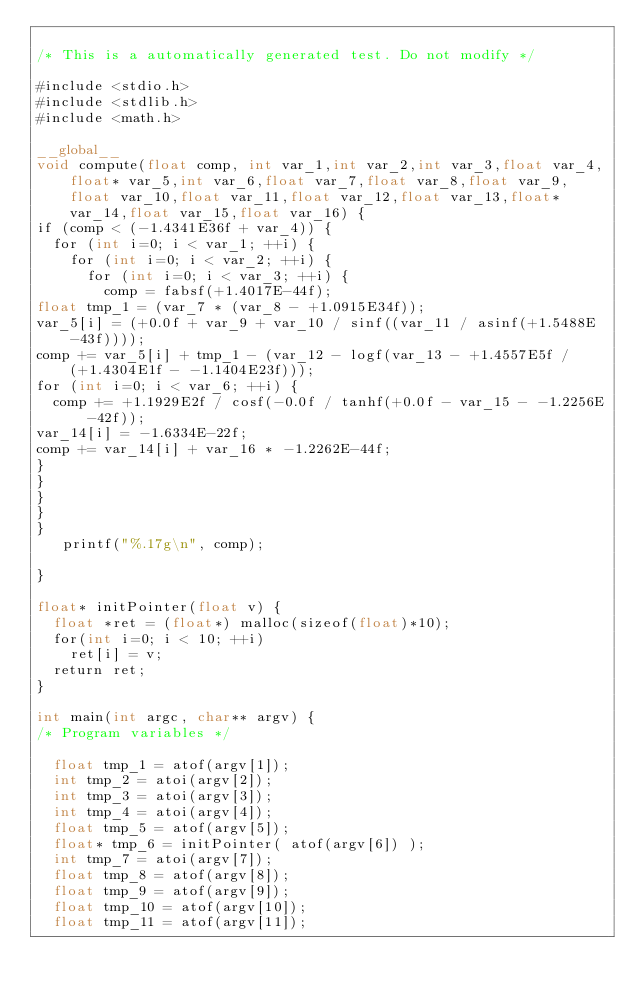Convert code to text. <code><loc_0><loc_0><loc_500><loc_500><_Cuda_>
/* This is a automatically generated test. Do not modify */

#include <stdio.h>
#include <stdlib.h>
#include <math.h>

__global__
void compute(float comp, int var_1,int var_2,int var_3,float var_4,float* var_5,int var_6,float var_7,float var_8,float var_9,float var_10,float var_11,float var_12,float var_13,float* var_14,float var_15,float var_16) {
if (comp < (-1.4341E36f + var_4)) {
  for (int i=0; i < var_1; ++i) {
    for (int i=0; i < var_2; ++i) {
      for (int i=0; i < var_3; ++i) {
        comp = fabsf(+1.4017E-44f);
float tmp_1 = (var_7 * (var_8 - +1.0915E34f));
var_5[i] = (+0.0f + var_9 + var_10 / sinf((var_11 / asinf(+1.5488E-43f))));
comp += var_5[i] + tmp_1 - (var_12 - logf(var_13 - +1.4557E5f / (+1.4304E1f - -1.1404E23f)));
for (int i=0; i < var_6; ++i) {
  comp += +1.1929E2f / cosf(-0.0f / tanhf(+0.0f - var_15 - -1.2256E-42f));
var_14[i] = -1.6334E-22f;
comp += var_14[i] + var_16 * -1.2262E-44f;
}
}
}
}
}
   printf("%.17g\n", comp);

}

float* initPointer(float v) {
  float *ret = (float*) malloc(sizeof(float)*10);
  for(int i=0; i < 10; ++i)
    ret[i] = v;
  return ret;
}

int main(int argc, char** argv) {
/* Program variables */

  float tmp_1 = atof(argv[1]);
  int tmp_2 = atoi(argv[2]);
  int tmp_3 = atoi(argv[3]);
  int tmp_4 = atoi(argv[4]);
  float tmp_5 = atof(argv[5]);
  float* tmp_6 = initPointer( atof(argv[6]) );
  int tmp_7 = atoi(argv[7]);
  float tmp_8 = atof(argv[8]);
  float tmp_9 = atof(argv[9]);
  float tmp_10 = atof(argv[10]);
  float tmp_11 = atof(argv[11]);</code> 